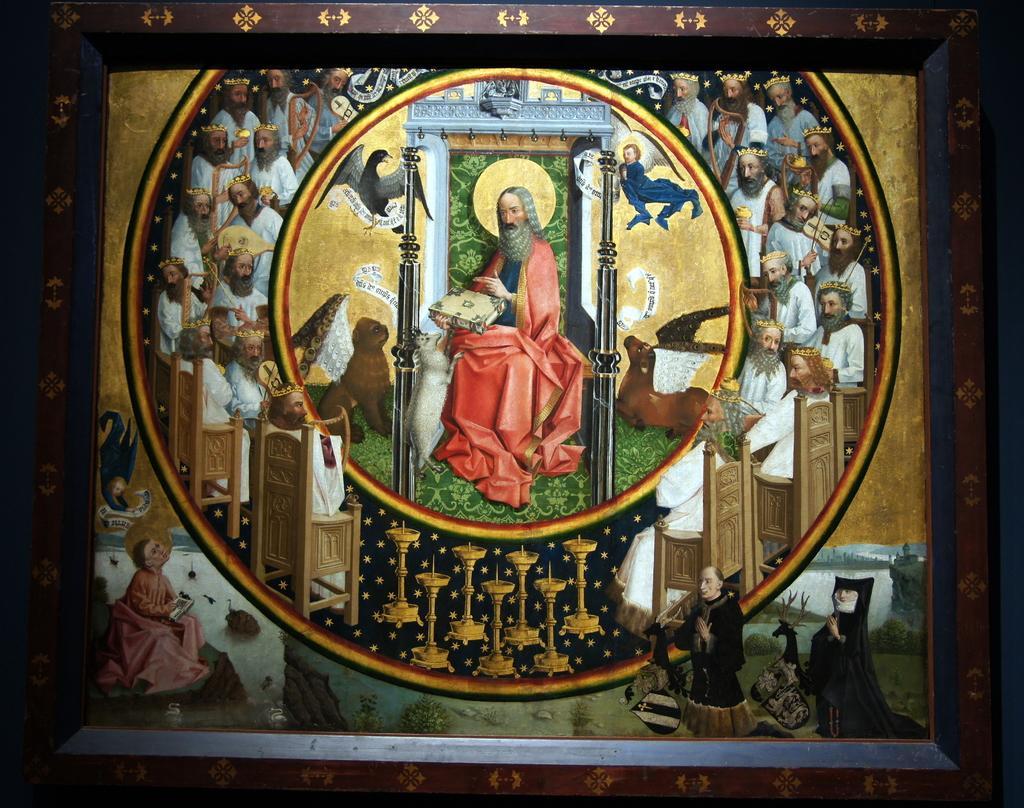Could you give a brief overview of what you see in this image? In this image we can see a photo frame in which we can see group of people sitting on chairs. In the center of the image we can see a person holding a object in his hand , we can also see group of animals , birds, plants and water. 